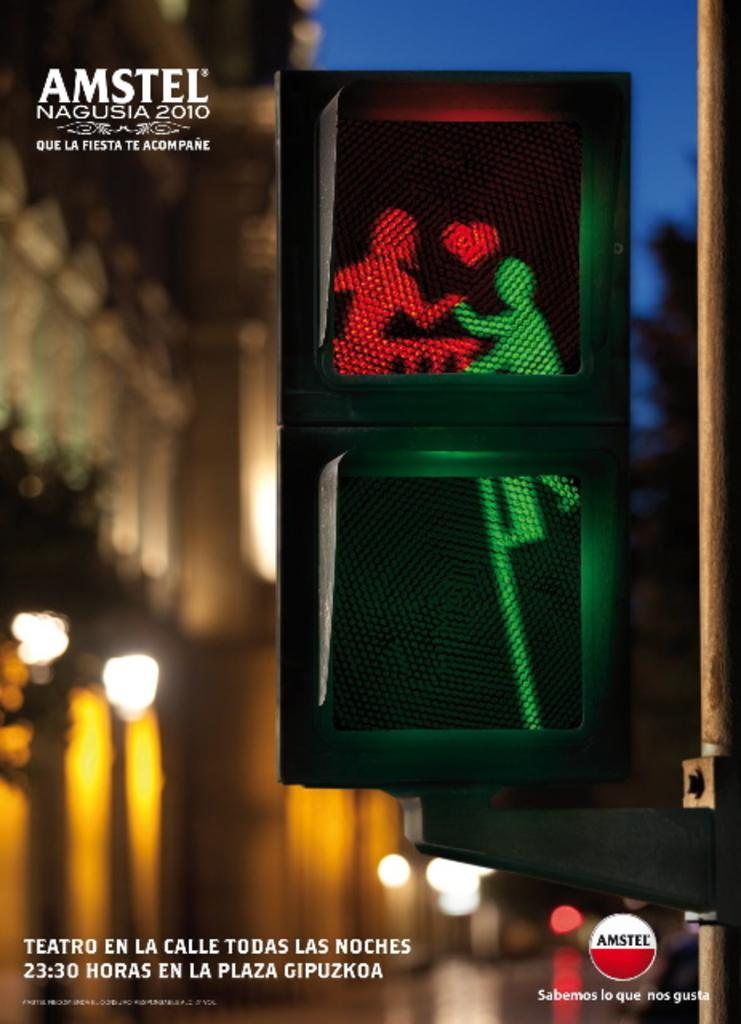<image>
Share a concise interpretation of the image provided. Street sign with a logo below it which says AMSTEL. 